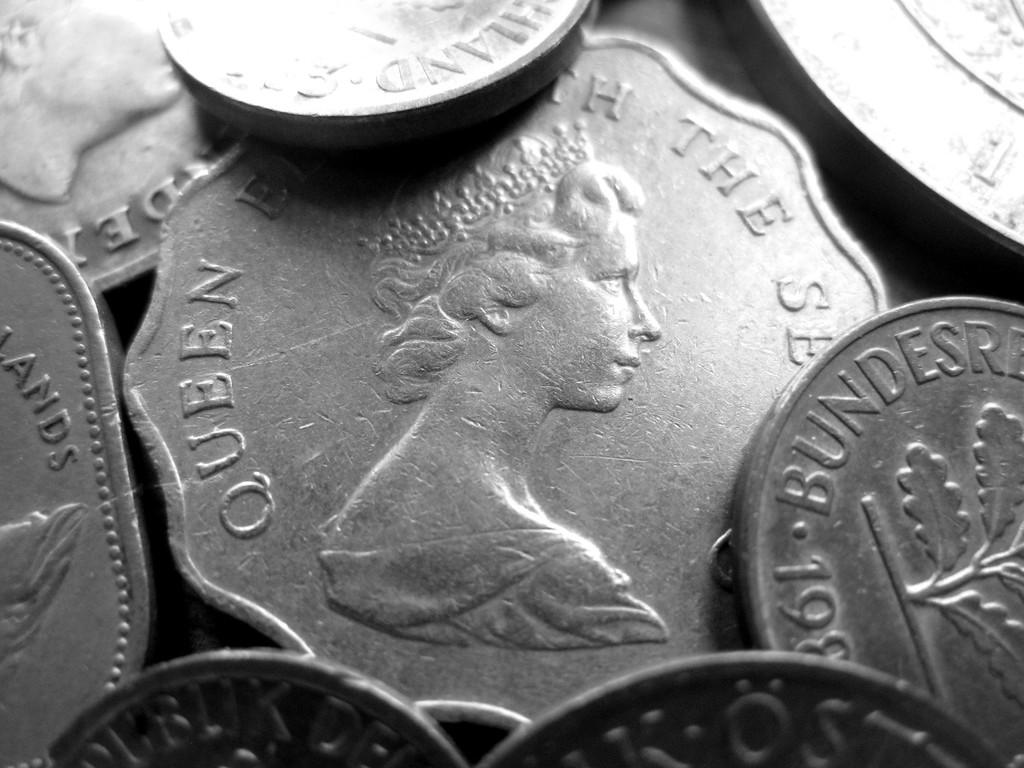Provide a one-sentence caption for the provided image. A pile of silver coins that say Bundersre and feature a queen. 